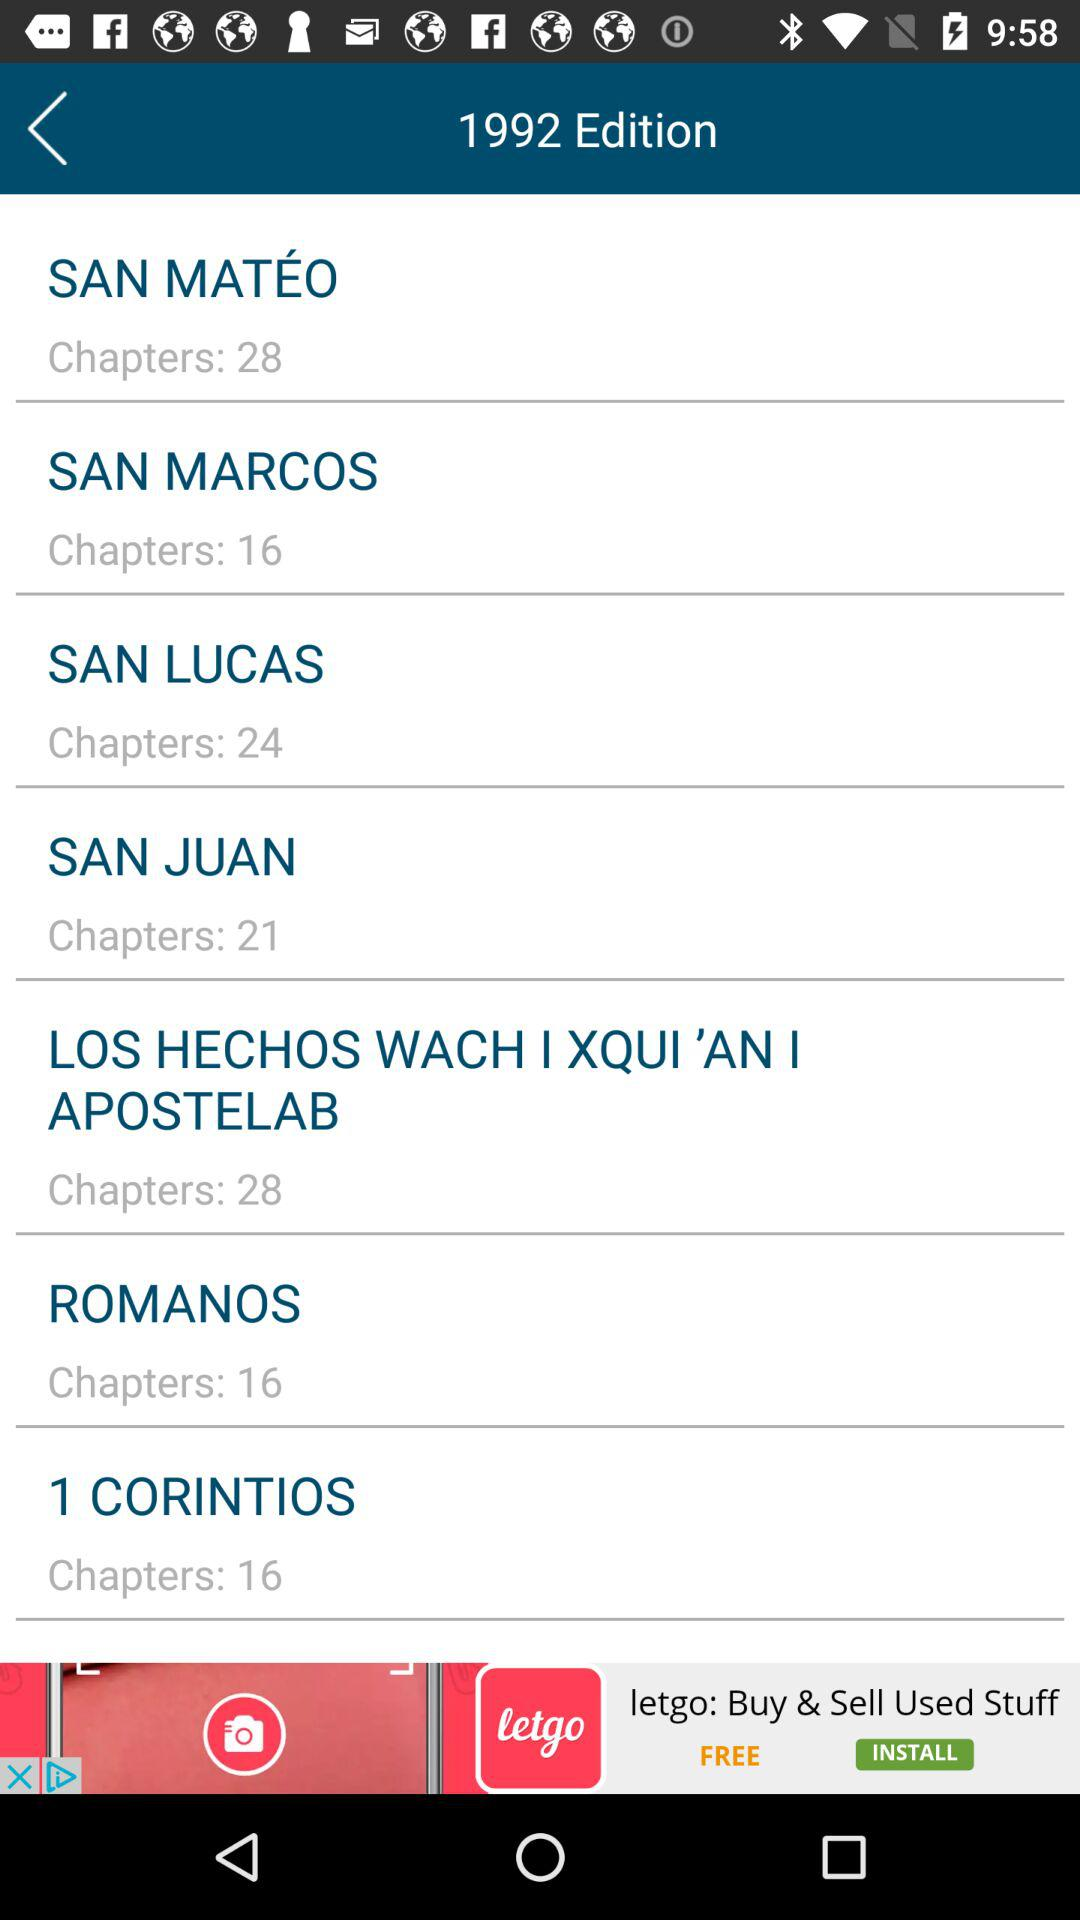What is the edition number? The edition number is 1992. 